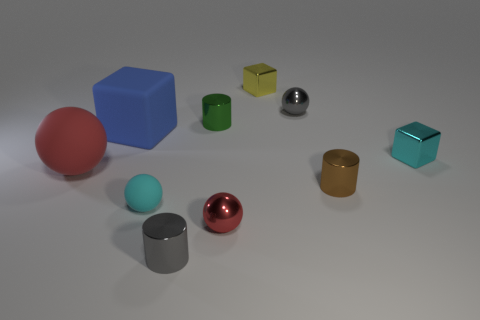Subtract all cyan spheres. How many spheres are left? 3 Subtract all purple balls. Subtract all red blocks. How many balls are left? 4 Subtract all balls. How many objects are left? 6 Subtract all tiny blue cylinders. Subtract all green metal objects. How many objects are left? 9 Add 8 small metallic blocks. How many small metallic blocks are left? 10 Add 6 small cyan metallic things. How many small cyan metallic things exist? 7 Subtract 0 green balls. How many objects are left? 10 